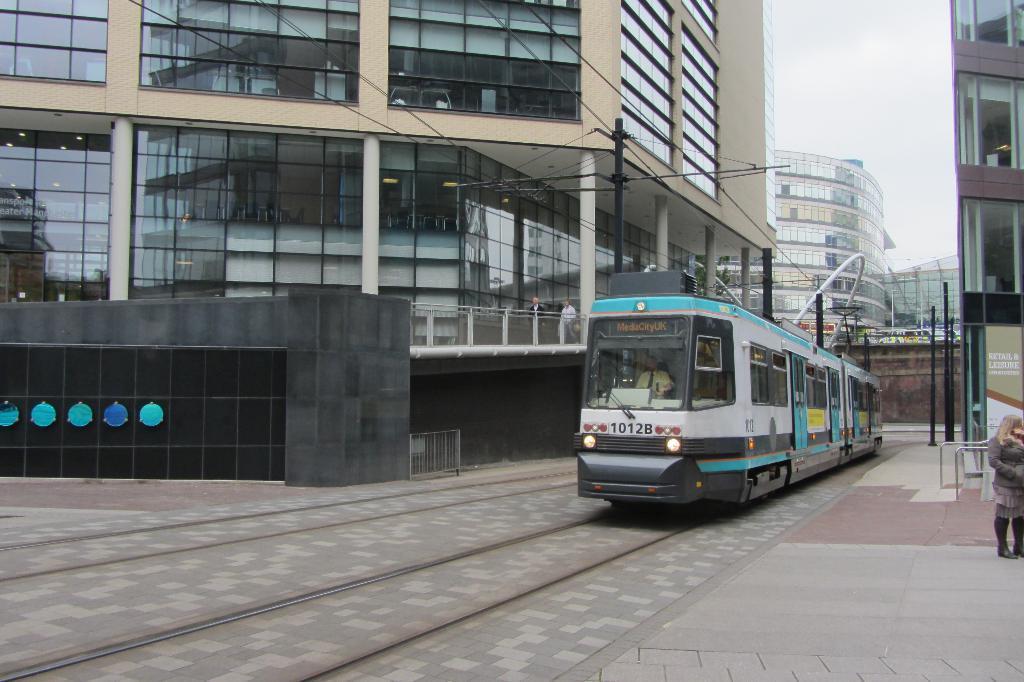In one or two sentences, can you explain what this image depicts? In the middle of the image there is a locomotive. Behind the locomotive there are some poles and buildings. At the top of the image there are some clouds and sky. 